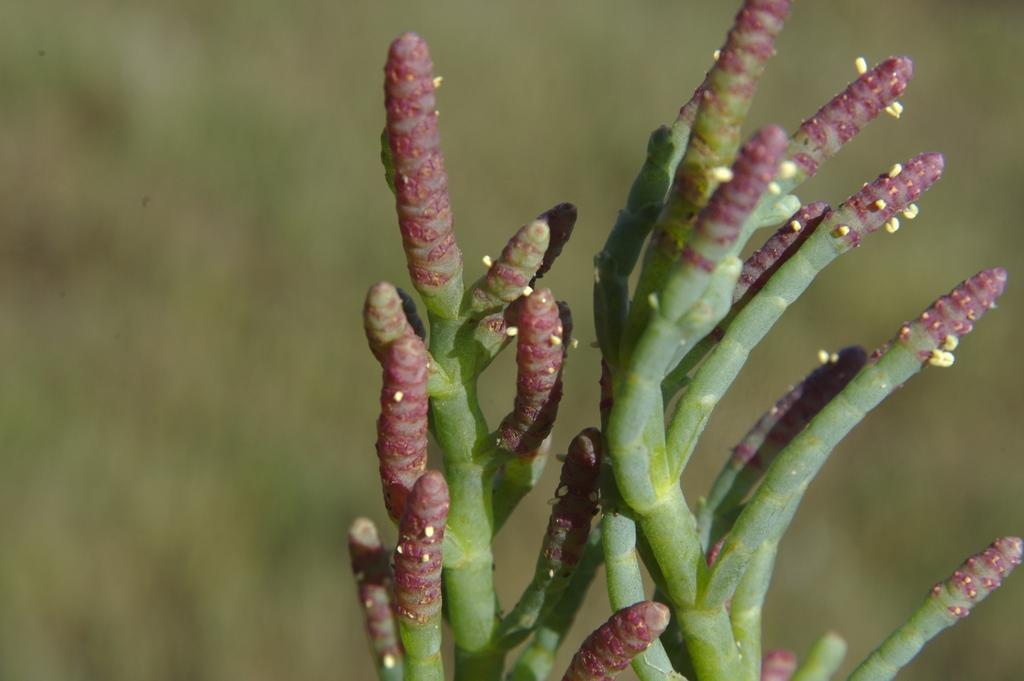What type of plant is present in the image? There is estuary pickleweed in the image. Can you describe the background of the image? The background area of the image is blurred. How many boats can be seen in the estuary pickleweed in the image? There are no boats present in the image; it only features estuary pickleweed. What type of mineral is visible in the estuary pickleweed in the image? There is no mineral, such as quartz, visible in the estuary pickleweed in the image. 